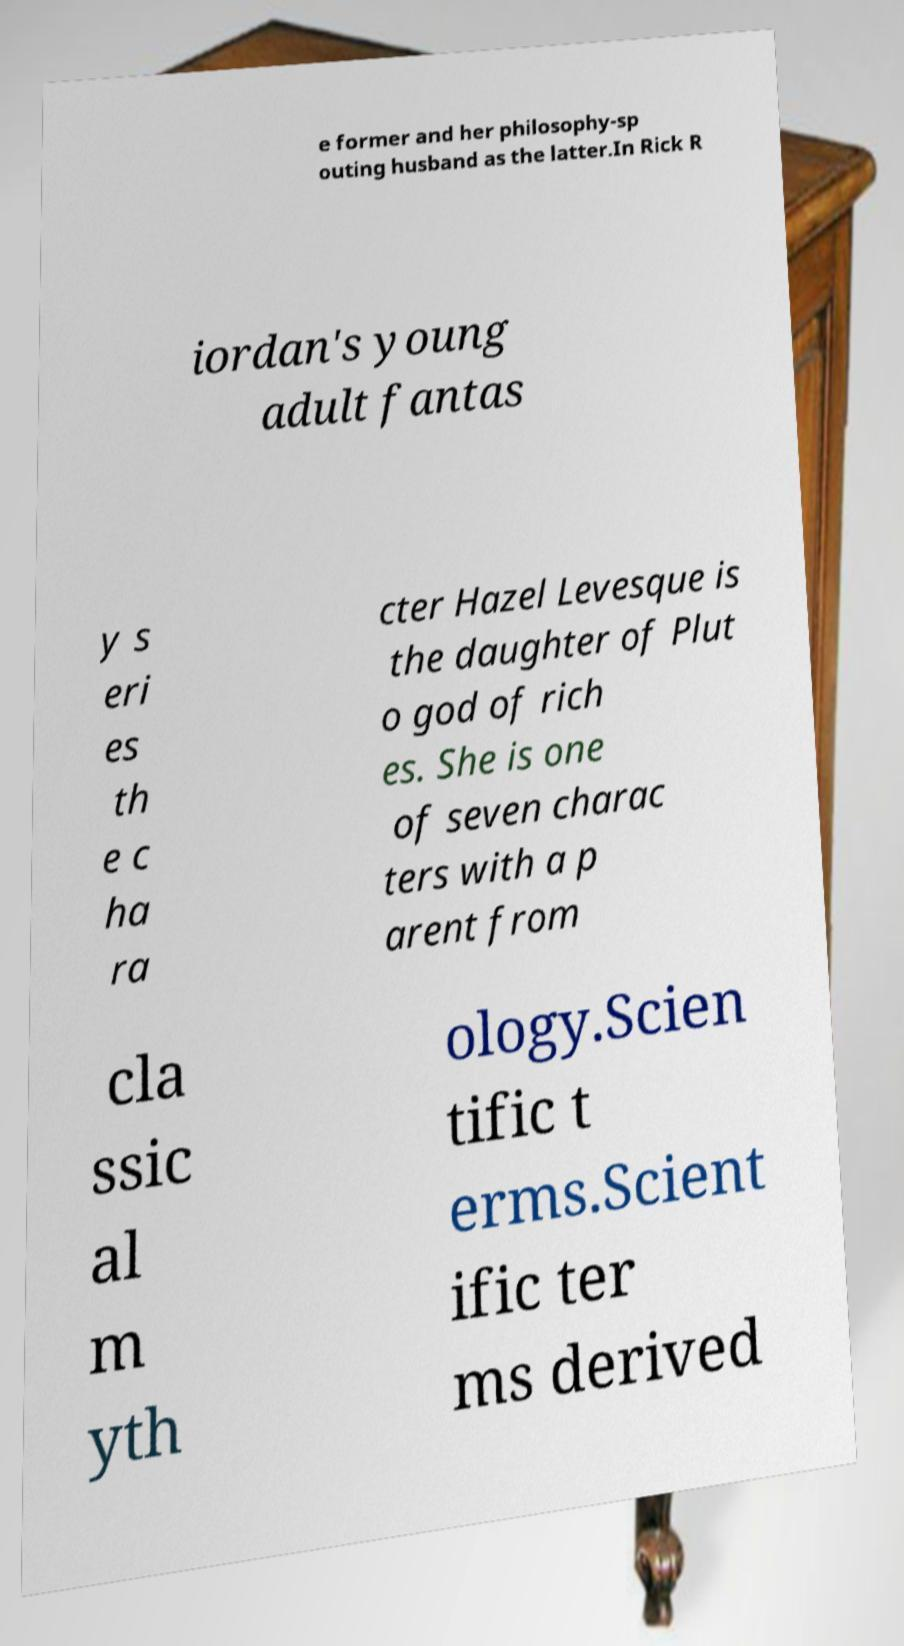Could you extract and type out the text from this image? e former and her philosophy-sp outing husband as the latter.In Rick R iordan's young adult fantas y s eri es th e c ha ra cter Hazel Levesque is the daughter of Plut o god of rich es. She is one of seven charac ters with a p arent from cla ssic al m yth ology.Scien tific t erms.Scient ific ter ms derived 